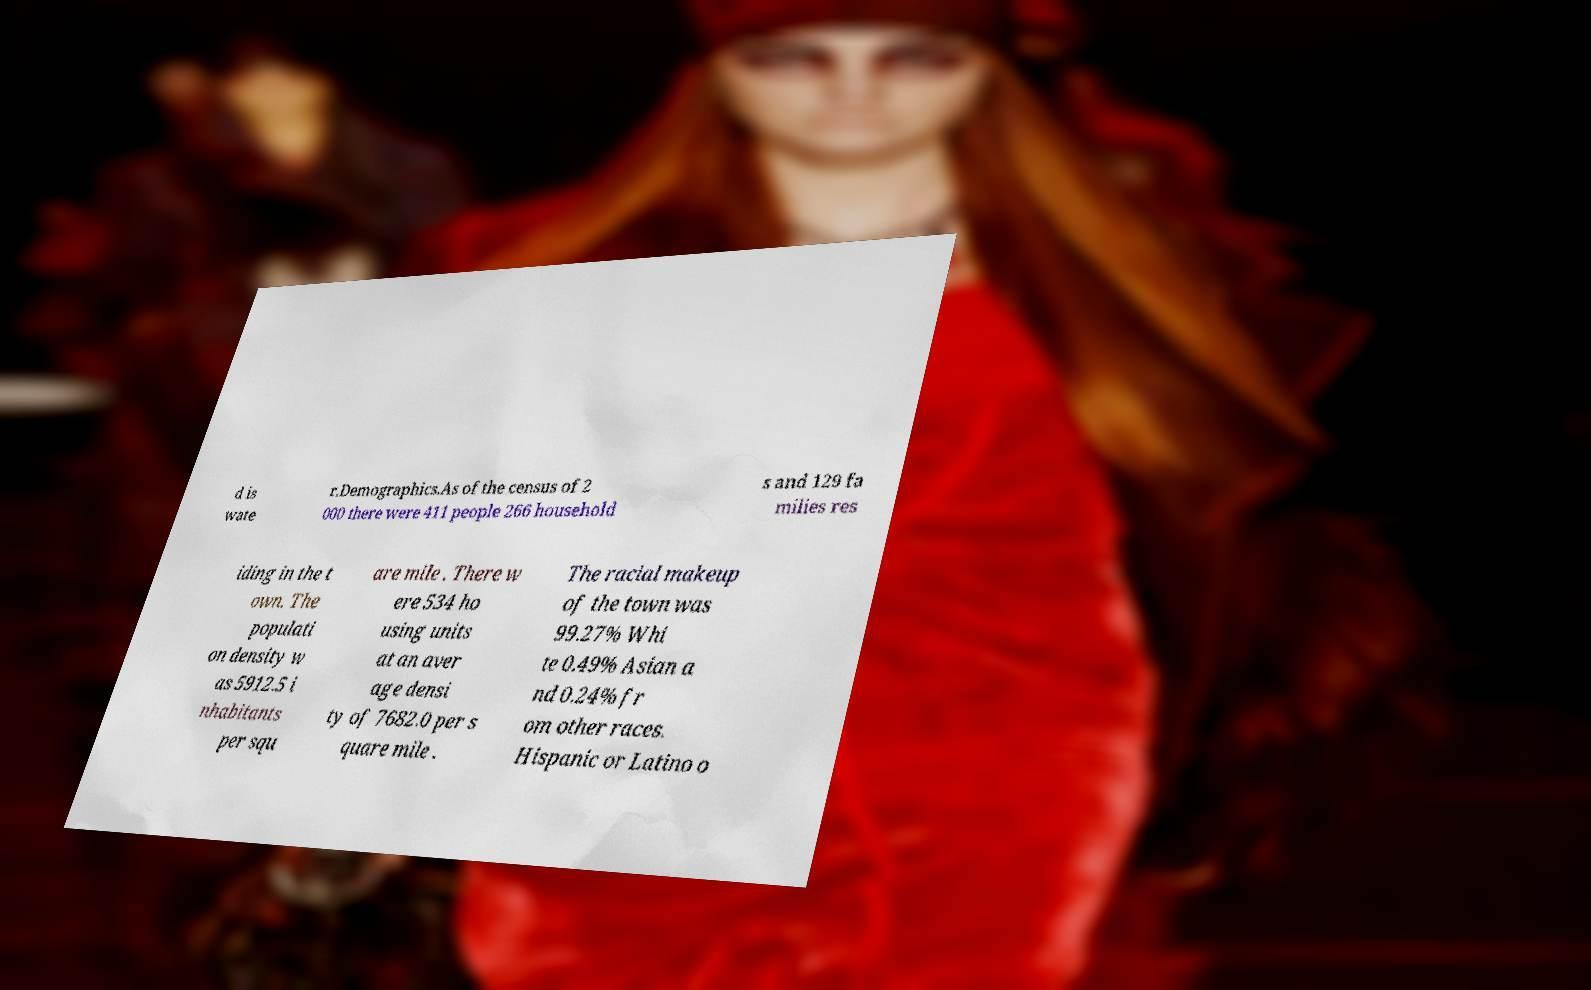Could you assist in decoding the text presented in this image and type it out clearly? d is wate r.Demographics.As of the census of 2 000 there were 411 people 266 household s and 129 fa milies res iding in the t own. The populati on density w as 5912.5 i nhabitants per squ are mile . There w ere 534 ho using units at an aver age densi ty of 7682.0 per s quare mile . The racial makeup of the town was 99.27% Whi te 0.49% Asian a nd 0.24% fr om other races. Hispanic or Latino o 